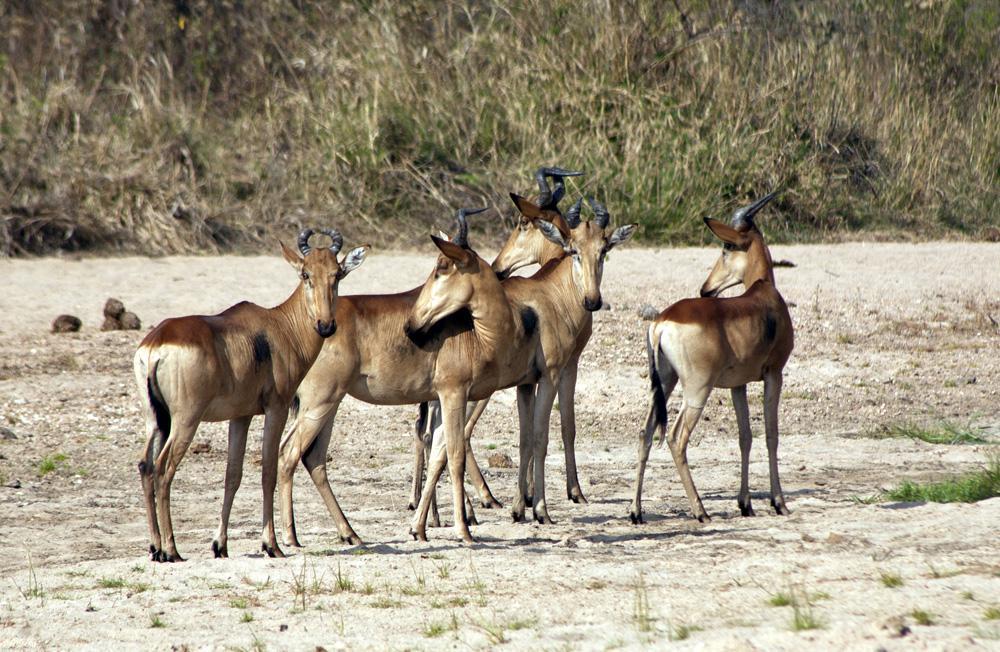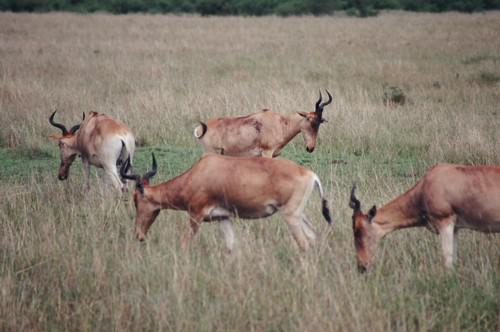The first image is the image on the left, the second image is the image on the right. Examine the images to the left and right. Is the description "There is a single brown dear with black antlers facing or walking right." accurate? Answer yes or no. No. The first image is the image on the left, the second image is the image on the right. Assess this claim about the two images: "There are more than 8 animals total.". Correct or not? Answer yes or no. Yes. 